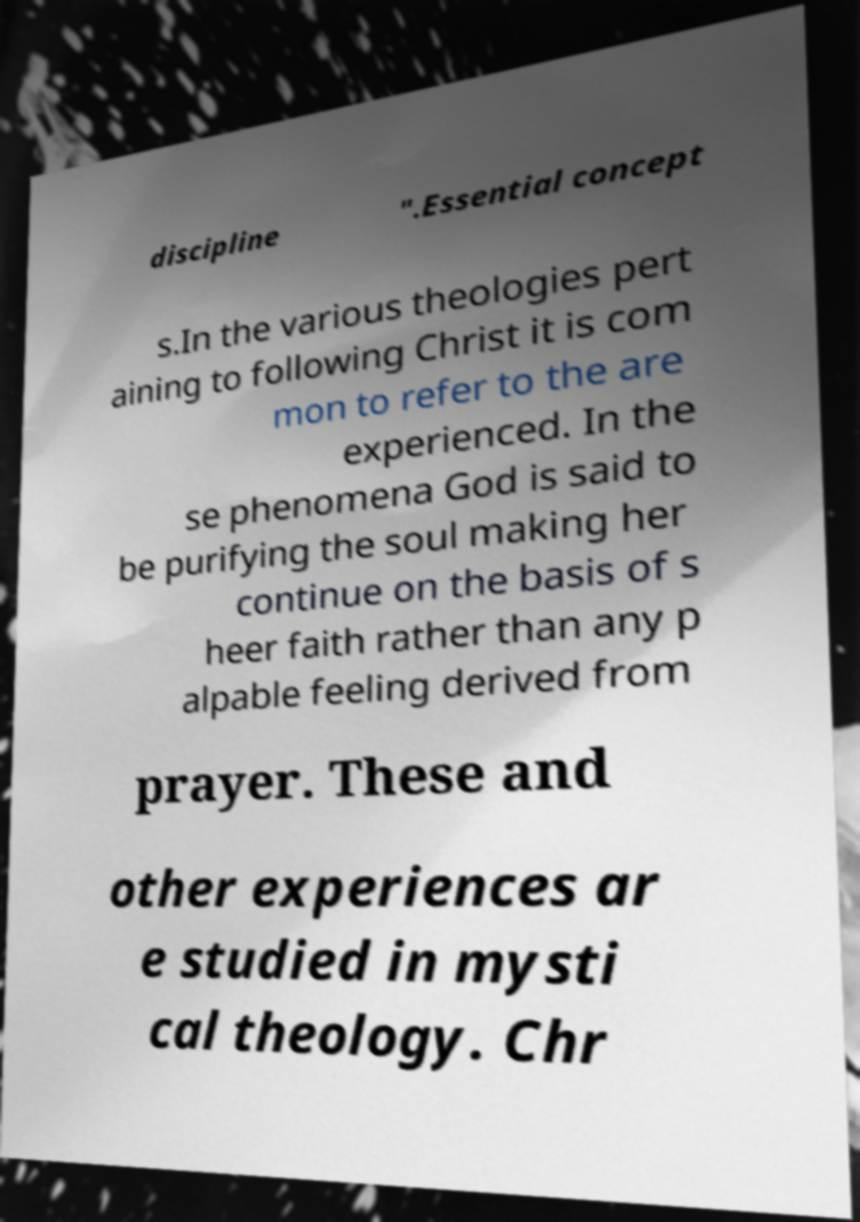There's text embedded in this image that I need extracted. Can you transcribe it verbatim? discipline ".Essential concept s.In the various theologies pert aining to following Christ it is com mon to refer to the are experienced. In the se phenomena God is said to be purifying the soul making her continue on the basis of s heer faith rather than any p alpable feeling derived from prayer. These and other experiences ar e studied in mysti cal theology. Chr 